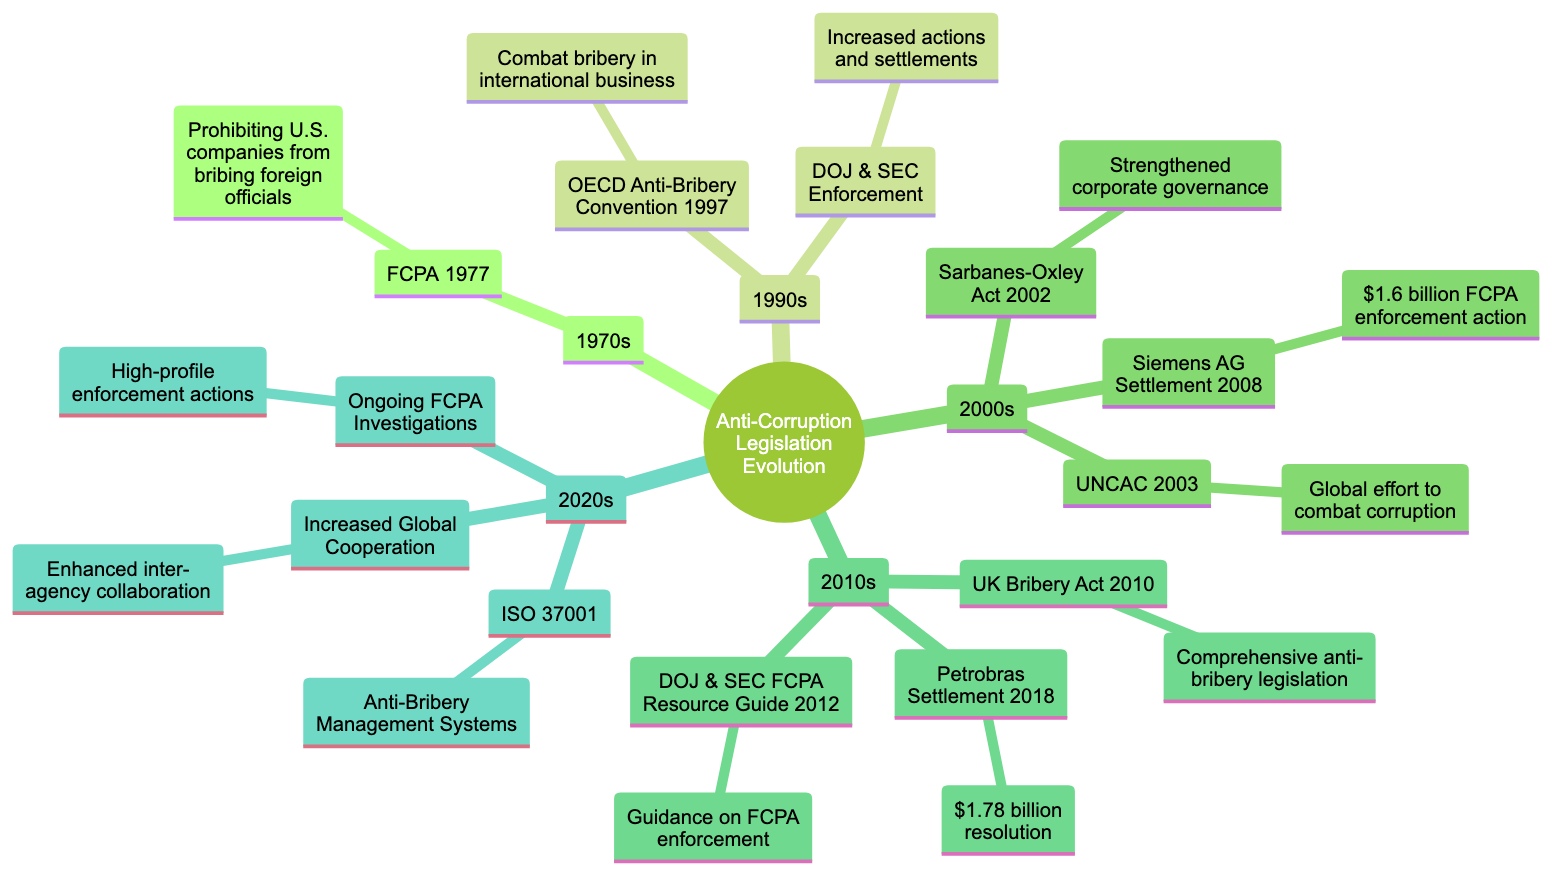What is the title of the root node? The title of the root node is provided at the top of the diagram, indicating the overall theme of the diagram which is "Evolution of Anti-Corruption Legislation and Key Enforcement Actions".
Answer: Evolution of Anti-Corruption Legislation and Key Enforcement Actions How many decades are represented in the diagram? By counting the nodes directly under the root, there are five distinct decades represented: 1970s, 1990s, 2000s, 2010s, and 2020s.
Answer: 5 Which enforcement action occurred in 2008? The 2008 action under the 2000s node refers to the Siemens AG Settlement which is an important FCPA enforcement action.
Answer: Siemens AG Settlement What major legislation was enacted in the 1970s? The major legislation enacted in the 1970s, as indicated in the dedicated child node, is the Foreign Corrupt Practices Act in 1977.
Answer: Foreign Corrupt Practices Act (1977) How does the OECD Anti-Bribery Convention of 1997 relate to the DOJ and SEC actions in the 1990s? In the 1990s section, after noting the OECD Anti-Bribery Convention's adoption in 1997, it's evident that it supported the increased enforcement actions by DOJ and SEC, signifying an international commitment to anti-bribery which coincided with U.S. actions.
Answer: Strengthened enforcement actions What was the monetary value associated with the Petrobras settlement in 2018? The Petrobras Settlement in the 2010s node specifically states that the resolution in this major corruption case was $1.78 billion.
Answer: $1.78 billion Which international standard was introduced in the 2020s? The ISO 37001, which provides guidelines for establishing anti-bribery management systems, is labeled as the new international standard introduced in the 2020s section of the diagram.
Answer: ISO 37001 What significant trend is noted in the 2020s regarding global enforcement? The 2020s section highlights the trend of increased global cooperation, indicating a more collaborative environment among international enforcement agencies.
Answer: Increased Global Cooperation Which decade's key events include the Sarbanes-Oxley Act? The key event of the Sarbanes-Oxley Act, which is related to corporate governance and impacts FCPA compliance, is found in the 2000s section of the diagram.
Answer: 2000s 